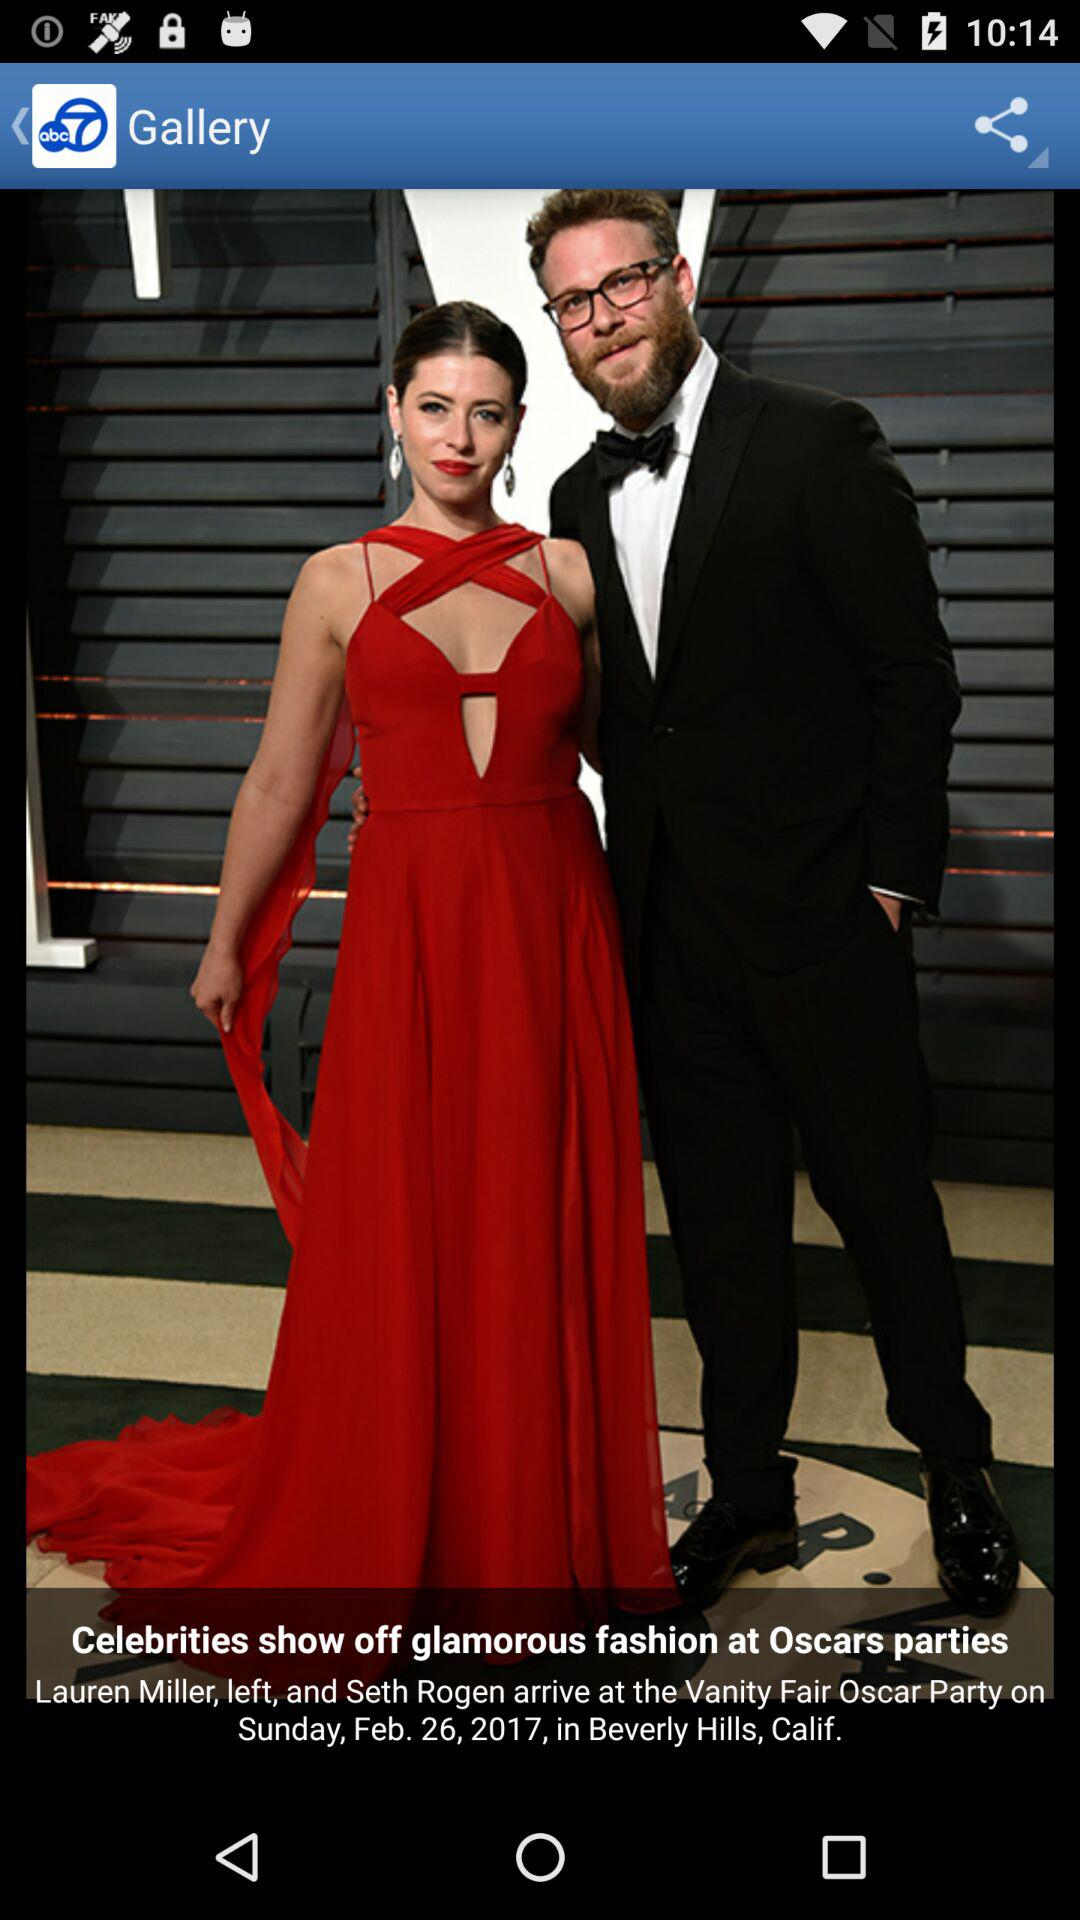What's the location of the party? The location is Beverly Hills, Calif. 